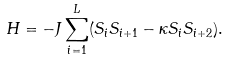<formula> <loc_0><loc_0><loc_500><loc_500>H = - J \sum _ { i = 1 } ^ { L } ( S _ { i } S _ { i + 1 } - \kappa S _ { i } S _ { i + 2 } ) .</formula> 